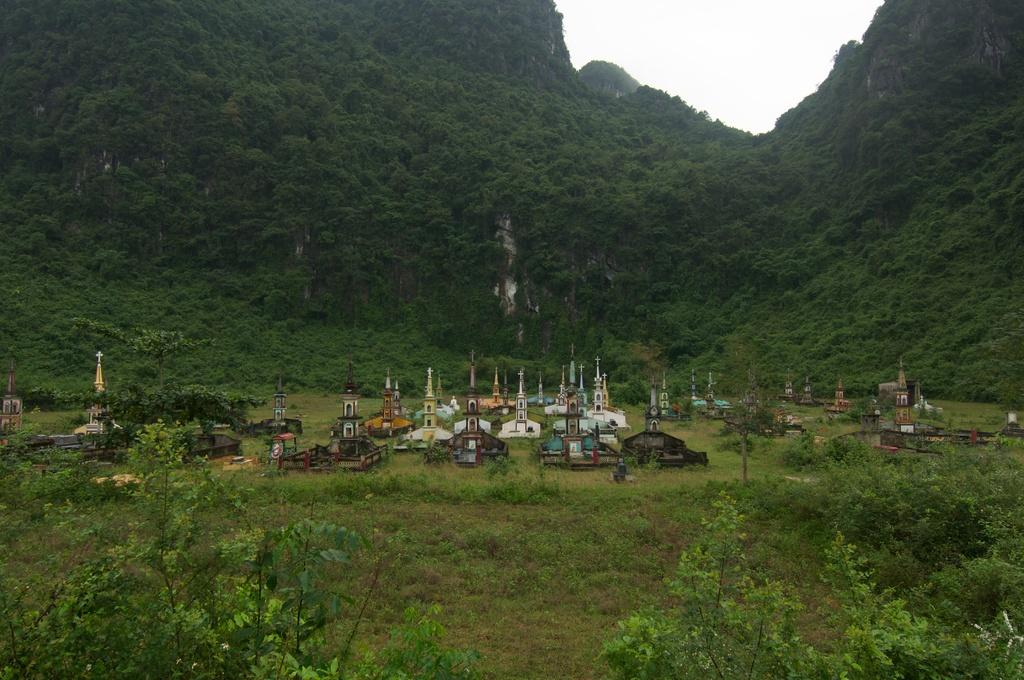What type of location is shown in the image? The location depicted in the image is a graveyard. What can be seen in the surroundings of the graveyard? There are many trees and plants around the graveyard. What is visible in the background of the image? There is a hill visible in the background. What is visible at the top of the image? The sky is visible at the top of the image. What type of lamp is used to light up the graveyard in the image? There is no lamp present in the image; it is a graveyard with natural lighting from the sky. 